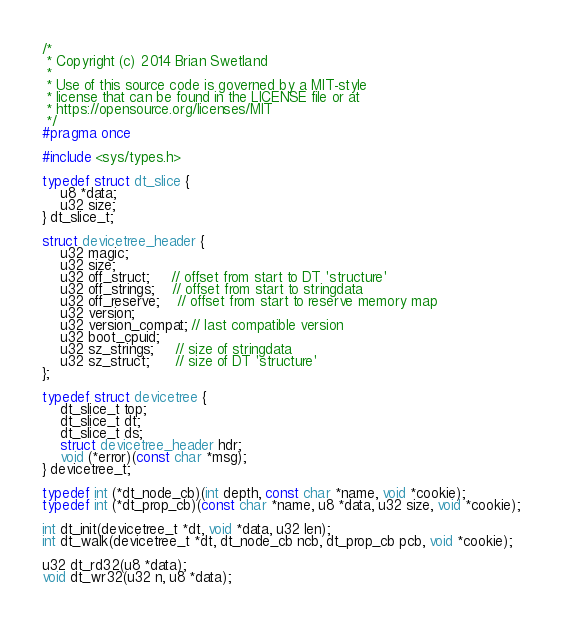Convert code to text. <code><loc_0><loc_0><loc_500><loc_500><_C_>/*
 * Copyright (c) 2014 Brian Swetland
 *
 * Use of this source code is governed by a MIT-style
 * license that can be found in the LICENSE file or at
 * https://opensource.org/licenses/MIT
 */
#pragma once

#include <sys/types.h>

typedef struct dt_slice {
    u8 *data;
    u32 size;
} dt_slice_t;

struct devicetree_header {
    u32 magic;
    u32 size;
    u32 off_struct;     // offset from start to DT 'structure'
    u32 off_strings;    // offset from start to stringdata
    u32 off_reserve;    // offset from start to reserve memory map
    u32 version;
    u32 version_compat; // last compatible version
    u32 boot_cpuid;
    u32 sz_strings;     // size of stringdata
    u32 sz_struct;      // size of DT 'structure'
};

typedef struct devicetree {
    dt_slice_t top;
    dt_slice_t dt;
    dt_slice_t ds;
    struct devicetree_header hdr;
    void (*error)(const char *msg);
} devicetree_t;

typedef int (*dt_node_cb)(int depth, const char *name, void *cookie);
typedef int (*dt_prop_cb)(const char *name, u8 *data, u32 size, void *cookie);

int dt_init(devicetree_t *dt, void *data, u32 len);
int dt_walk(devicetree_t *dt, dt_node_cb ncb, dt_prop_cb pcb, void *cookie);

u32 dt_rd32(u8 *data);
void dt_wr32(u32 n, u8 *data);

</code> 